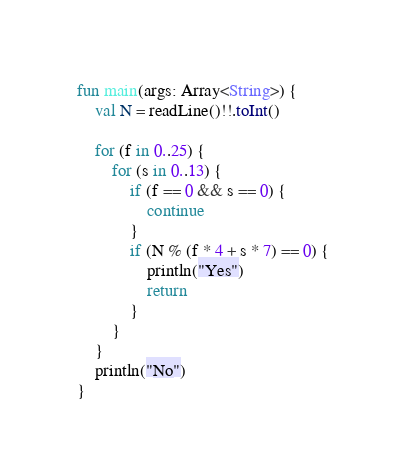Convert code to text. <code><loc_0><loc_0><loc_500><loc_500><_Kotlin_>fun main(args: Array<String>) {
    val N = readLine()!!.toInt()

    for (f in 0..25) {
        for (s in 0..13) {
            if (f == 0 && s == 0) {
                continue
            }
            if (N % (f * 4 + s * 7) == 0) {
                println("Yes")
                return
            }
        }
    }
    println("No")
}</code> 